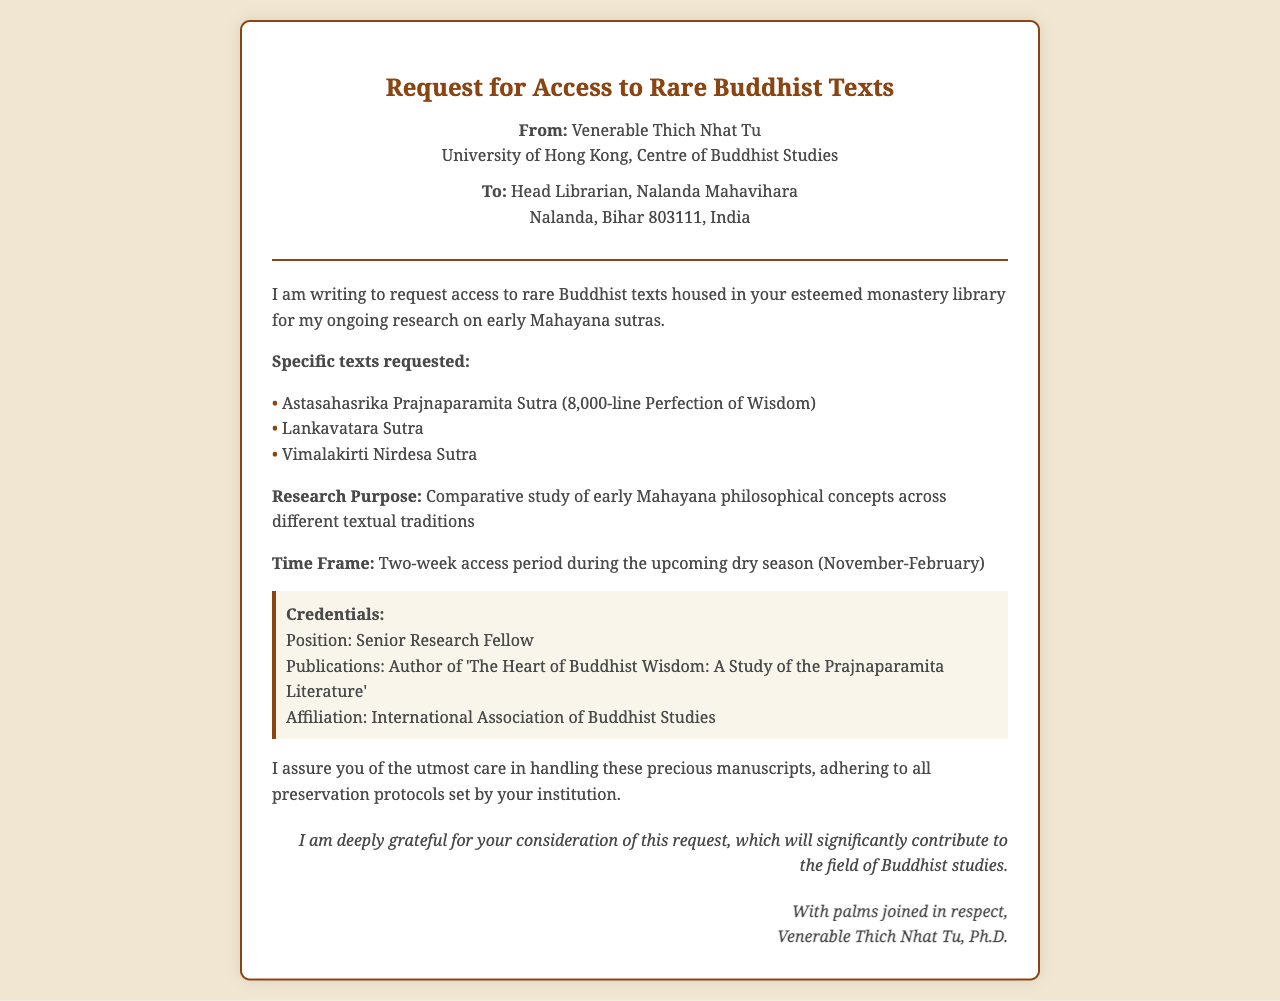What is the sender's name? The sender's name is mentioned at the beginning of the document.
Answer: Venerable Thich Nhat Tu What is the affiliation of the sender? The sender's affiliation is stated in the document under the sender's section.
Answer: University of Hong Kong, Centre of Buddhist Studies Which rare texts are requested? The document lists specific texts requested in a bullet format.
Answer: Astasahasrika Prajnaparamita Sutra, Lankavatara Sutra, Vimalakirti Nirdesa Sutra What is the research purpose? The purpose of the research is clearly stated in the document.
Answer: Comparative study of early Mahayana philosophical concepts across different textual traditions What is the time frame for accessing the texts? The time frame is specified in the body of the document.
Answer: Two-week access period during the upcoming dry season (November-February) What is the sender's position? The sender's position is provided in the credentials section of the document.
Answer: Senior Research Fellow What are the protocols assured for manuscript handling? The sender assures care and adherence to protocols in handling the manuscripts.
Answer: Adhering to all preservation protocols set by your institution What is the closing expression used by the sender? The closing expression can be found at the end of the document.
Answer: With palms joined in respect 